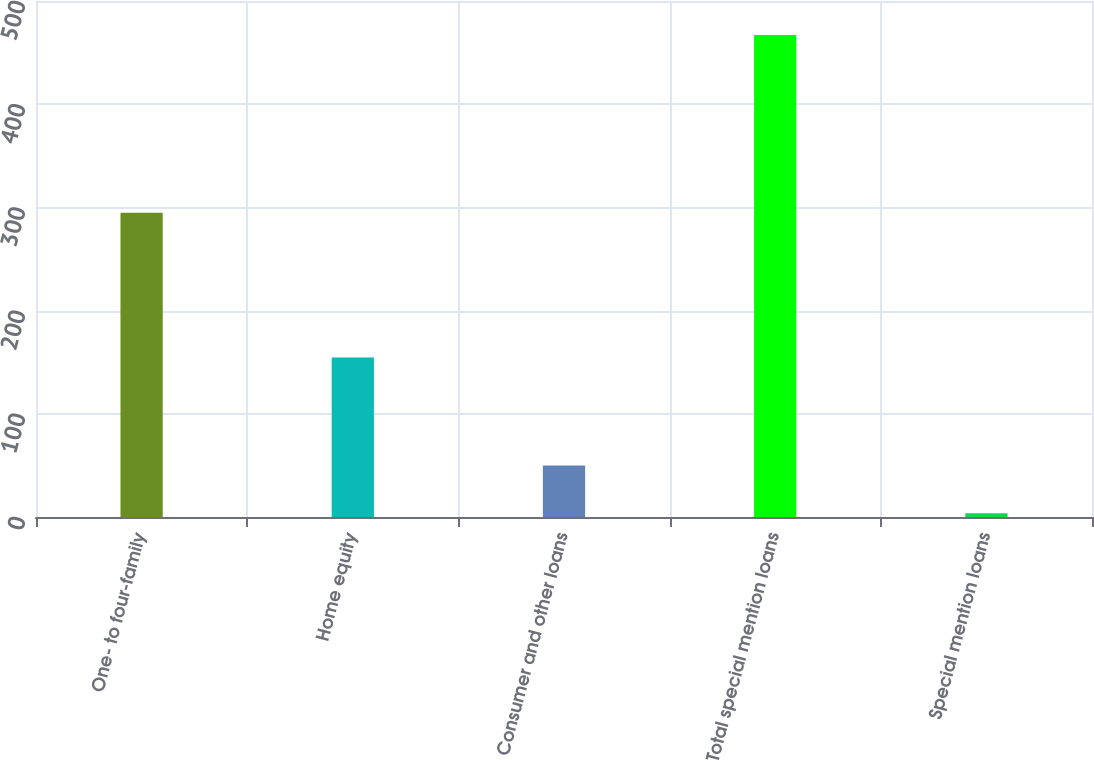Convert chart to OTSL. <chart><loc_0><loc_0><loc_500><loc_500><bar_chart><fcel>One- to four-family<fcel>Home equity<fcel>Consumer and other loans<fcel>Total special mention loans<fcel>Special mention loans<nl><fcel>294.8<fcel>154.6<fcel>49.91<fcel>467.1<fcel>3.55<nl></chart> 